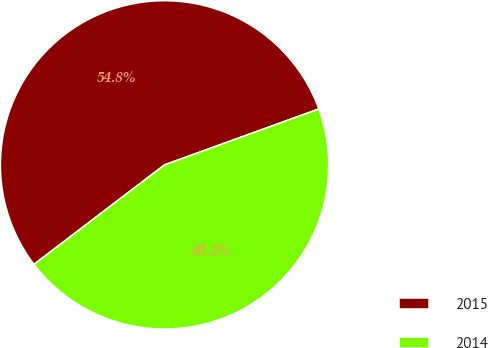Convert chart to OTSL. <chart><loc_0><loc_0><loc_500><loc_500><pie_chart><fcel>2015<fcel>2014<nl><fcel>54.83%<fcel>45.17%<nl></chart> 